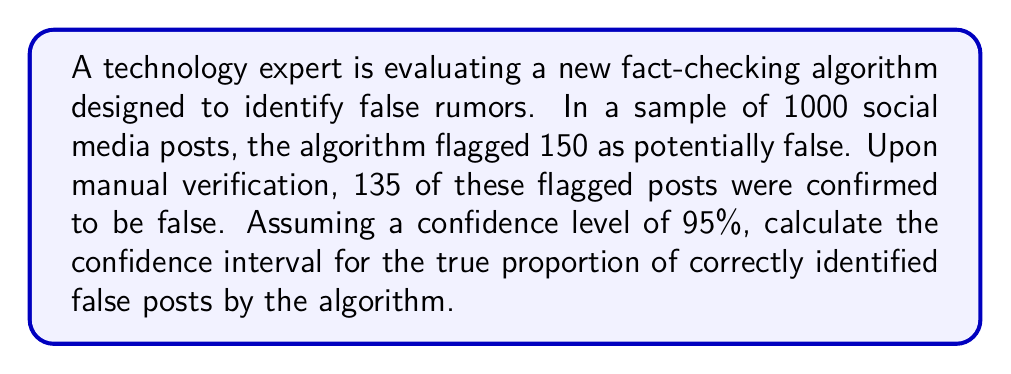Give your solution to this math problem. To solve this problem, we'll use the following steps:

1) First, let's identify our variables:
   $n$ = sample size = 150 (flagged posts)
   $\hat{p}$ = sample proportion = 135/150 = 0.9

2) The formula for the confidence interval is:

   $$\hat{p} \pm z_{\alpha/2} \sqrt{\frac{\hat{p}(1-\hat{p})}{n}}$$

   Where $z_{\alpha/2}$ is the critical value for the desired confidence level.

3) For a 95% confidence level, $z_{\alpha/2} = 1.96$

4) Now, let's substitute our values:

   $$0.9 \pm 1.96 \sqrt{\frac{0.9(1-0.9)}{150}}$$

5) Simplify under the square root:

   $$0.9 \pm 1.96 \sqrt{\frac{0.09}{150}}$$

6) Calculate:

   $$0.9 \pm 1.96 \sqrt{0.0006}$$
   $$0.9 \pm 1.96 (0.0245)$$
   $$0.9 \pm 0.048$$

7) Therefore, the confidence interval is:

   $$(0.9 - 0.048, 0.9 + 0.048)$$
   $$(0.852, 0.948)$$

This means we can be 95% confident that the true proportion of correctly identified false posts by the algorithm is between 85.2% and 94.8%.
Answer: (0.852, 0.948) 